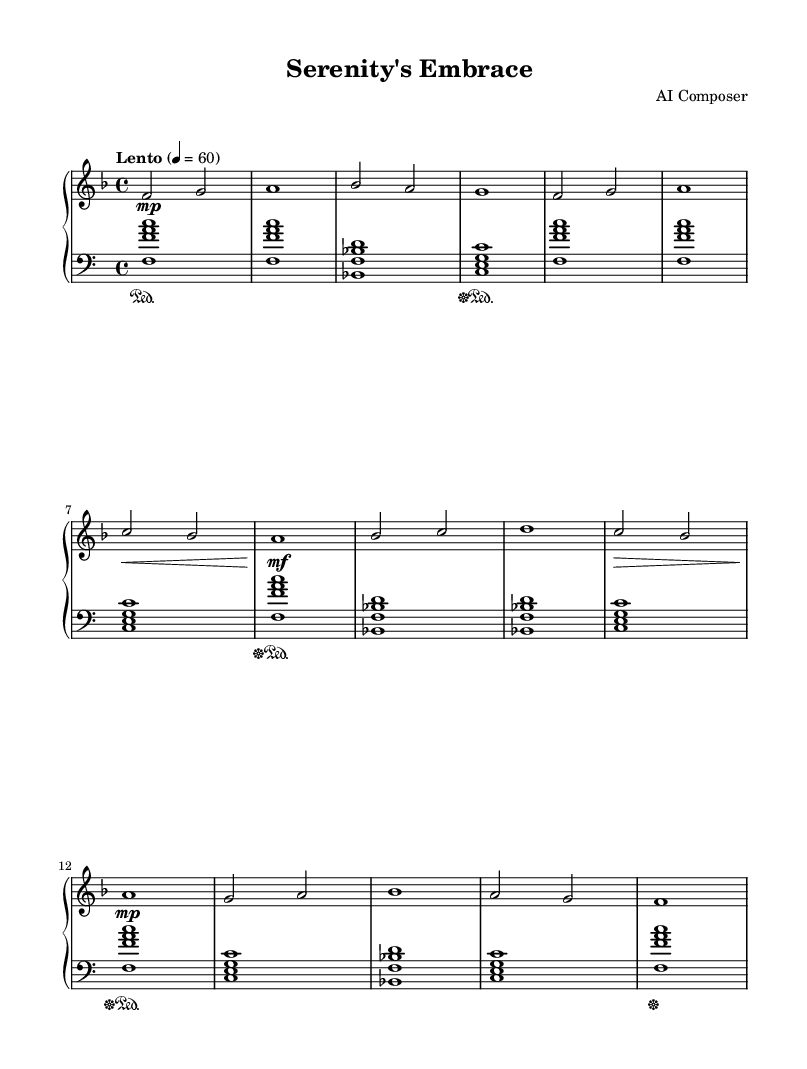What is the key signature of this music? The key signature indicates that there are one flat (B♭) in the key, which determines that the piece is in F major.
Answer: F major What is the time signature of this piece? The time signature is displayed at the beginning of the piece as 4/4, which means there are four beats in each measure, and each beat is a quarter note.
Answer: 4/4 What is the tempo marking for this composition? The tempo marking shows "Lento," which instructs the performer to play the piece at a slow tempo (around 60 beats per minute).
Answer: Lento How many measures are there in the melody? Counting the individual statements of the melody, we can see there are a total of 16 measures in the melody section.
Answer: 16 What is the dynamic marking at the beginning of the piece? The dynamic marking at the start indicates a soft sound (piano), represented by the symbol "p," which tells the player to play gently.
Answer: piano Which chord appears most frequently in the harmonies? The chord <f f' a c> appears most often as it is repeated multiple times throughout the piece, reinforcing the harmonic foundation.
Answer: <f f' a c> How many distinct sections are there in the theme of this piece? Analyzing the melody structure, we can identify four distinct sections based on the phrase pattern and musical ideas presented.
Answer: 4 